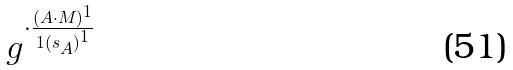<formula> <loc_0><loc_0><loc_500><loc_500>g ^ { \cdot \frac { ( A \cdot M ) ^ { 1 } } { 1 { ( s _ { A } ) } ^ { 1 } } }</formula> 